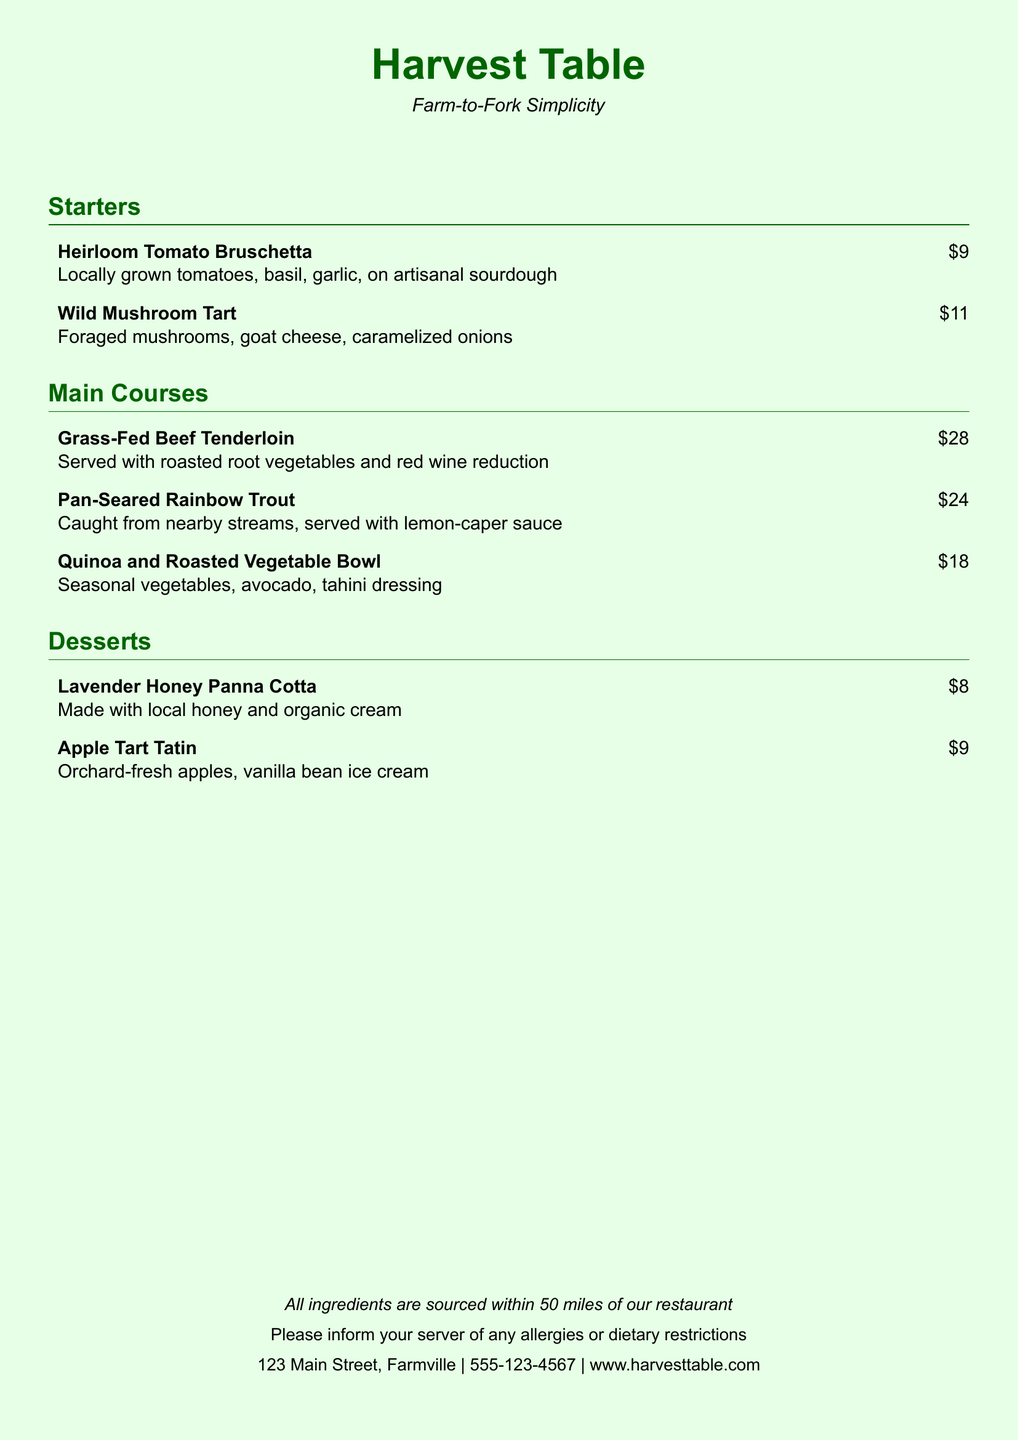What is the name of the restaurant? The restaurant is named "Harvest Table" as noted at the beginning of the menu.
Answer: Harvest Table What type of menu is presented? The menu highlights "Farm-to-Fork Simplicity," indicating a focus on locally-sourced ingredients.
Answer: Farm-to-Fork Simplicity What is the price of the Heirloom Tomato Bruschetta? The price listed for the Heirloom Tomato Bruschetta is specified in the menu.
Answer: $9 How many main courses are listed on the menu? The document includes three items under the main courses section, which contributes to the total count.
Answer: 3 What dessert features local honey? The dessert made with local honey is specifically mentioned in the description.
Answer: Lavender Honey Panna Cotta What is the main ingredient in the Quinoa and Roasted Vegetable Bowl? The main ingredient highlighted in the description is prominently mentioned.
Answer: Quinoa What is the address of the restaurant? The address is provided at the bottom of the document.
Answer: 123 Main Street, Farmville How far are all ingredients sourced from the restaurant? The document states a specific distance for ingredient sourcing.
Answer: 50 miles What is the phone number for the restaurant? The phone number for contact is noted in the menu.
Answer: 555-123-4567 